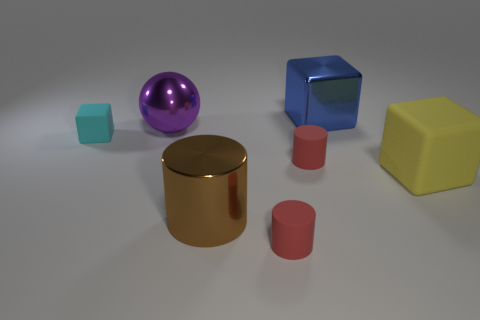Is there a big brown metal cube?
Your answer should be very brief. No. Do the blue cube and the large object on the left side of the large brown metal thing have the same material?
Your response must be concise. Yes. Are there more tiny rubber things in front of the tiny cyan block than large green matte objects?
Provide a succinct answer. Yes. Are there the same number of cyan rubber things that are in front of the brown object and matte objects right of the small cube?
Ensure brevity in your answer.  No. What is the big cube that is behind the purple shiny ball made of?
Ensure brevity in your answer.  Metal. What number of things are cyan rubber blocks that are on the left side of the yellow cube or brown cylinders?
Give a very brief answer. 2. How many other objects are the same shape as the purple metal object?
Provide a short and direct response. 0. There is a tiny red matte object behind the big matte cube; is it the same shape as the big brown metallic object?
Offer a very short reply. Yes. Are there any red objects to the left of the big metallic block?
Your answer should be compact. Yes. What number of small things are either shiny objects or brown balls?
Keep it short and to the point. 0. 